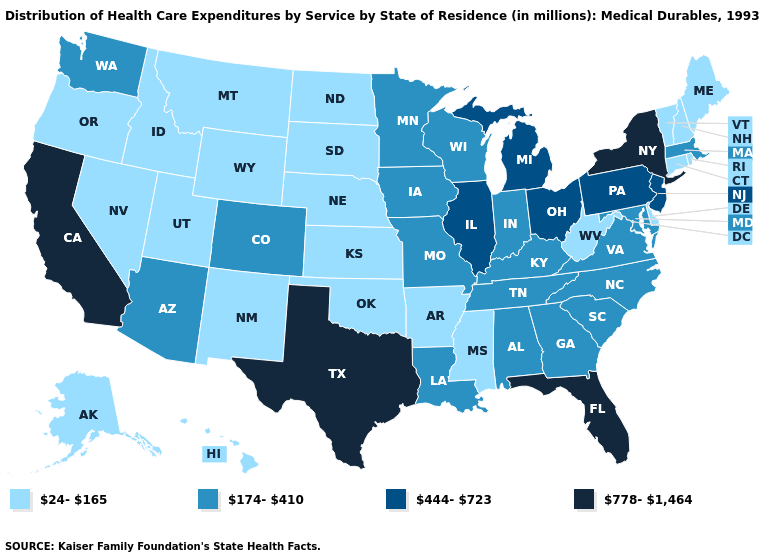Does Oregon have the lowest value in the USA?
Give a very brief answer. Yes. Does Oklahoma have the same value as Arkansas?
Answer briefly. Yes. Which states hav the highest value in the West?
Answer briefly. California. Name the states that have a value in the range 24-165?
Write a very short answer. Alaska, Arkansas, Connecticut, Delaware, Hawaii, Idaho, Kansas, Maine, Mississippi, Montana, Nebraska, Nevada, New Hampshire, New Mexico, North Dakota, Oklahoma, Oregon, Rhode Island, South Dakota, Utah, Vermont, West Virginia, Wyoming. Which states hav the highest value in the Northeast?
Give a very brief answer. New York. Is the legend a continuous bar?
Short answer required. No. Among the states that border Iowa , which have the lowest value?
Be succinct. Nebraska, South Dakota. Name the states that have a value in the range 24-165?
Give a very brief answer. Alaska, Arkansas, Connecticut, Delaware, Hawaii, Idaho, Kansas, Maine, Mississippi, Montana, Nebraska, Nevada, New Hampshire, New Mexico, North Dakota, Oklahoma, Oregon, Rhode Island, South Dakota, Utah, Vermont, West Virginia, Wyoming. Does the first symbol in the legend represent the smallest category?
Write a very short answer. Yes. What is the value of Vermont?
Give a very brief answer. 24-165. Does Wyoming have a lower value than Alabama?
Short answer required. Yes. What is the value of Maryland?
Write a very short answer. 174-410. Name the states that have a value in the range 778-1,464?
Answer briefly. California, Florida, New York, Texas. What is the lowest value in the West?
Answer briefly. 24-165. Among the states that border Utah , does Nevada have the highest value?
Be succinct. No. 